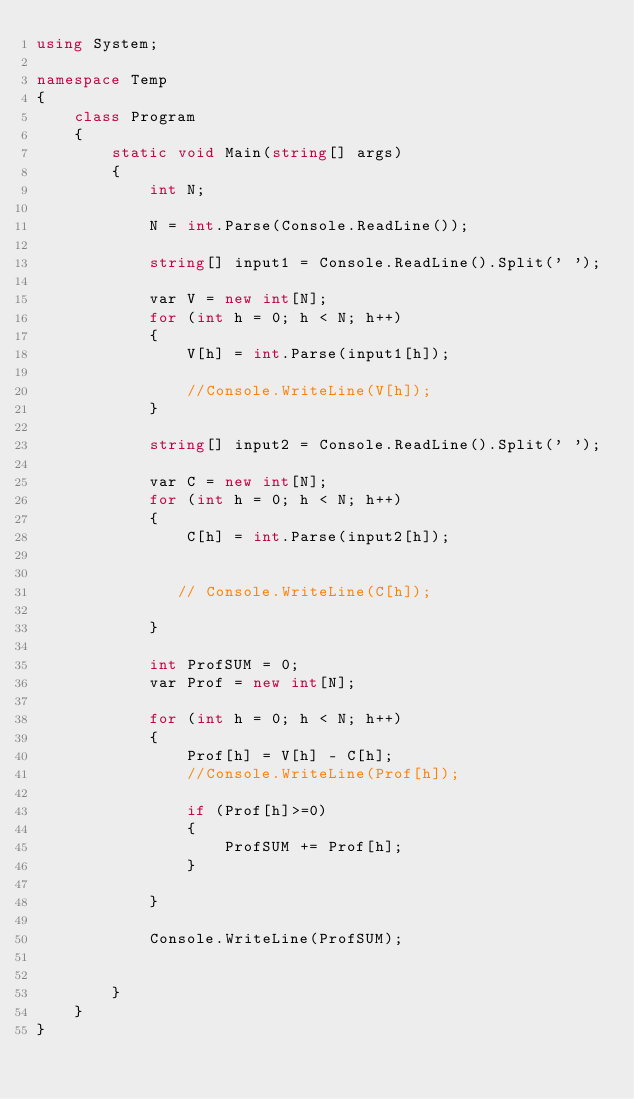Convert code to text. <code><loc_0><loc_0><loc_500><loc_500><_C#_>using System;

namespace Temp
{
    class Program
    {
        static void Main(string[] args)
        {
            int N;

            N = int.Parse(Console.ReadLine());

            string[] input1 = Console.ReadLine().Split(' ');

            var V = new int[N];
            for (int h = 0; h < N; h++)
            {
                V[h] = int.Parse(input1[h]);

                //Console.WriteLine(V[h]);
            }

            string[] input2 = Console.ReadLine().Split(' ');

            var C = new int[N];
            for (int h = 0; h < N; h++)
            {
                C[h] = int.Parse(input2[h]);


               // Console.WriteLine(C[h]);

            }

            int ProfSUM = 0;
            var Prof = new int[N];

            for (int h = 0; h < N; h++)
            {
                Prof[h] = V[h] - C[h];
                //Console.WriteLine(Prof[h]);

                if (Prof[h]>=0)
                {
                    ProfSUM += Prof[h];
                }

            }

            Console.WriteLine(ProfSUM);


        }
    }
}</code> 